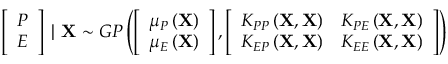Convert formula to latex. <formula><loc_0><loc_0><loc_500><loc_500>\left [ \begin{array} { c } { P } \\ { E } \end{array} \right ] | X \sim G P \left ( \left [ \begin{array} { c } { \mu _ { P } \left ( X \right ) } \\ { \mu _ { E } \left ( X \right ) } \end{array} \right ] , \left [ \begin{array} { c c } { K _ { P P } \left ( X , X \right ) } & { K _ { P E } \left ( X , X \right ) } \\ { K _ { E P } \left ( X , X \right ) } & { K _ { E E } \left ( X , X \right ) } \end{array} \right ] \right )</formula> 